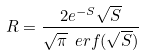<formula> <loc_0><loc_0><loc_500><loc_500>R = \frac { 2 e ^ { - S } \sqrt { S } } { \sqrt { \pi } \ e r f ( \sqrt { S } ) }</formula> 